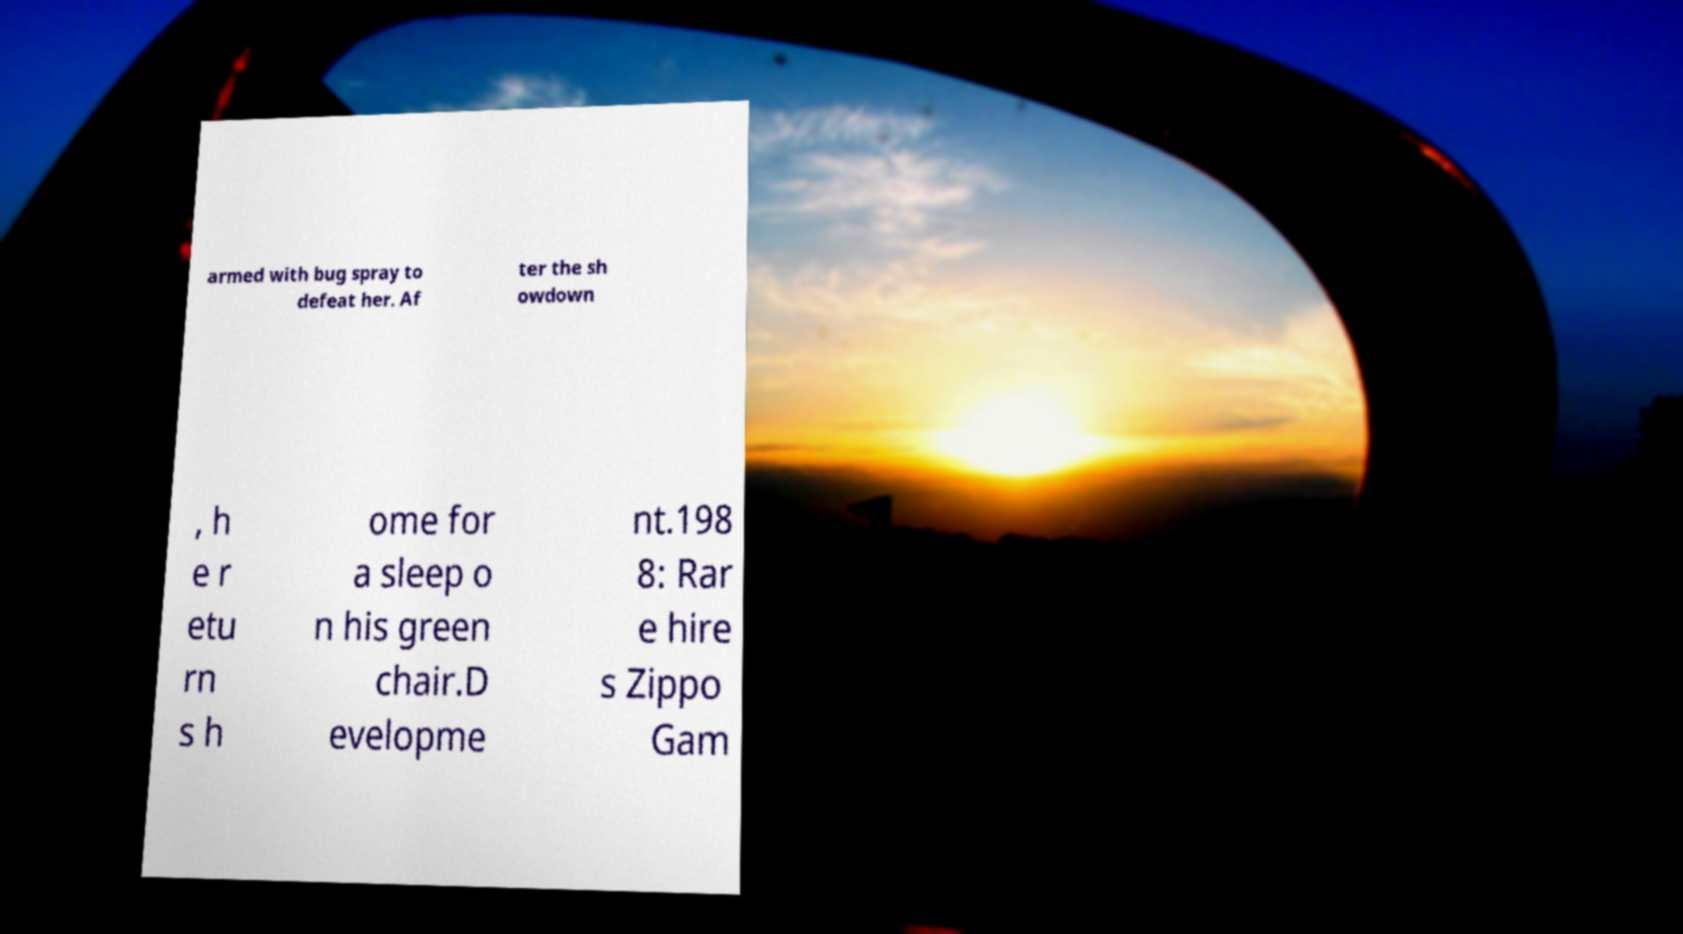What messages or text are displayed in this image? I need them in a readable, typed format. armed with bug spray to defeat her. Af ter the sh owdown , h e r etu rn s h ome for a sleep o n his green chair.D evelopme nt.198 8: Rar e hire s Zippo Gam 